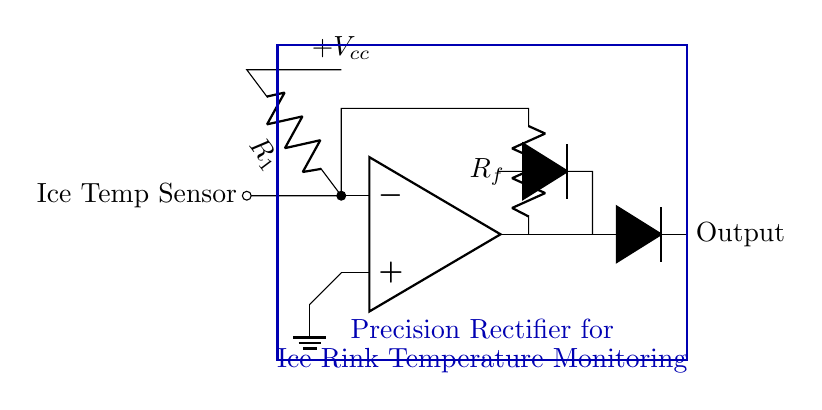What is the component used for temperature sensing? The component used for temperature sensing in this circuit is labeled as "Ice Temp Sensor" connected to the inverting input of the op-amp.
Answer: Ice Temp Sensor What type of rectifier is represented in this circuit? This circuit is a precision rectifier, which allows for accurate rectification of small signals by using operational amplifiers and diodes.
Answer: Precision rectifier What is the role of the feedback resistor R_f? The feedback resistor R_f is used to control the gain of the operational amplifier, which influences the output signal in relation to the input signal from the ice temperature sensor.
Answer: Control gain How many diodes are present in the circuit? The circuit contains two diodes, which are essential for the rectification process.
Answer: Two Which part of the circuit connects to the ground? The non-inverting input of the operational amplifier is connected to the ground, indicated by the ground symbol under the op-amp.
Answer: Non-inverting input What voltage supply is indicated for this circuit? The circuit indicates a positive voltage supply of V_cc, which powers the operational amplifier and ensures proper functioning of the rectifier.
Answer: Plus V_cc 